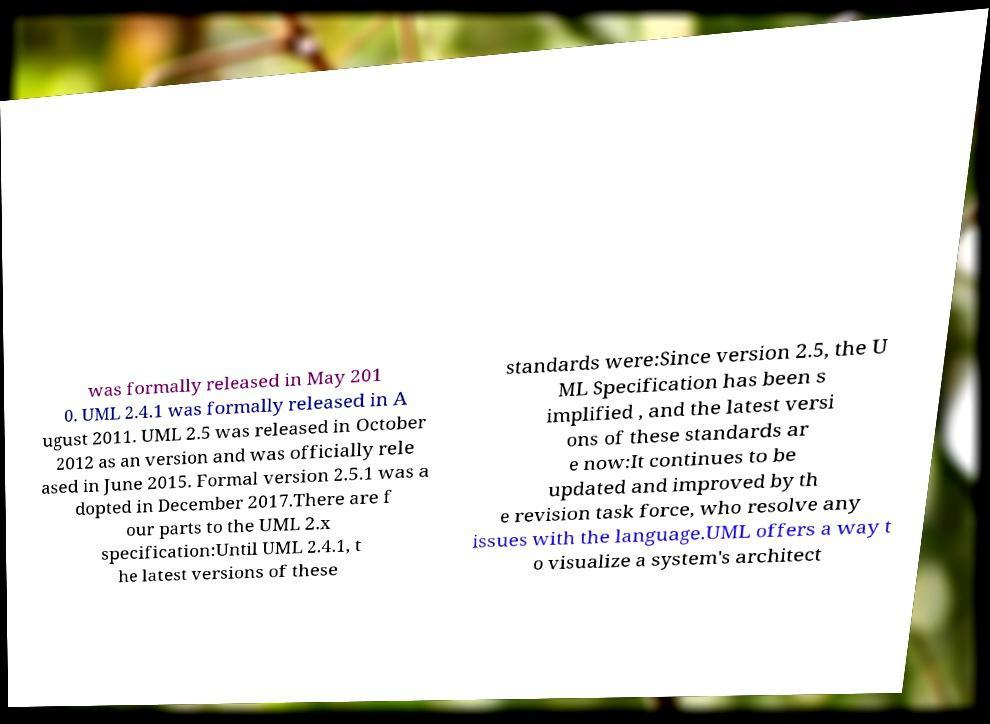Can you accurately transcribe the text from the provided image for me? was formally released in May 201 0. UML 2.4.1 was formally released in A ugust 2011. UML 2.5 was released in October 2012 as an version and was officially rele ased in June 2015. Formal version 2.5.1 was a dopted in December 2017.There are f our parts to the UML 2.x specification:Until UML 2.4.1, t he latest versions of these standards were:Since version 2.5, the U ML Specification has been s implified , and the latest versi ons of these standards ar e now:It continues to be updated and improved by th e revision task force, who resolve any issues with the language.UML offers a way t o visualize a system's architect 